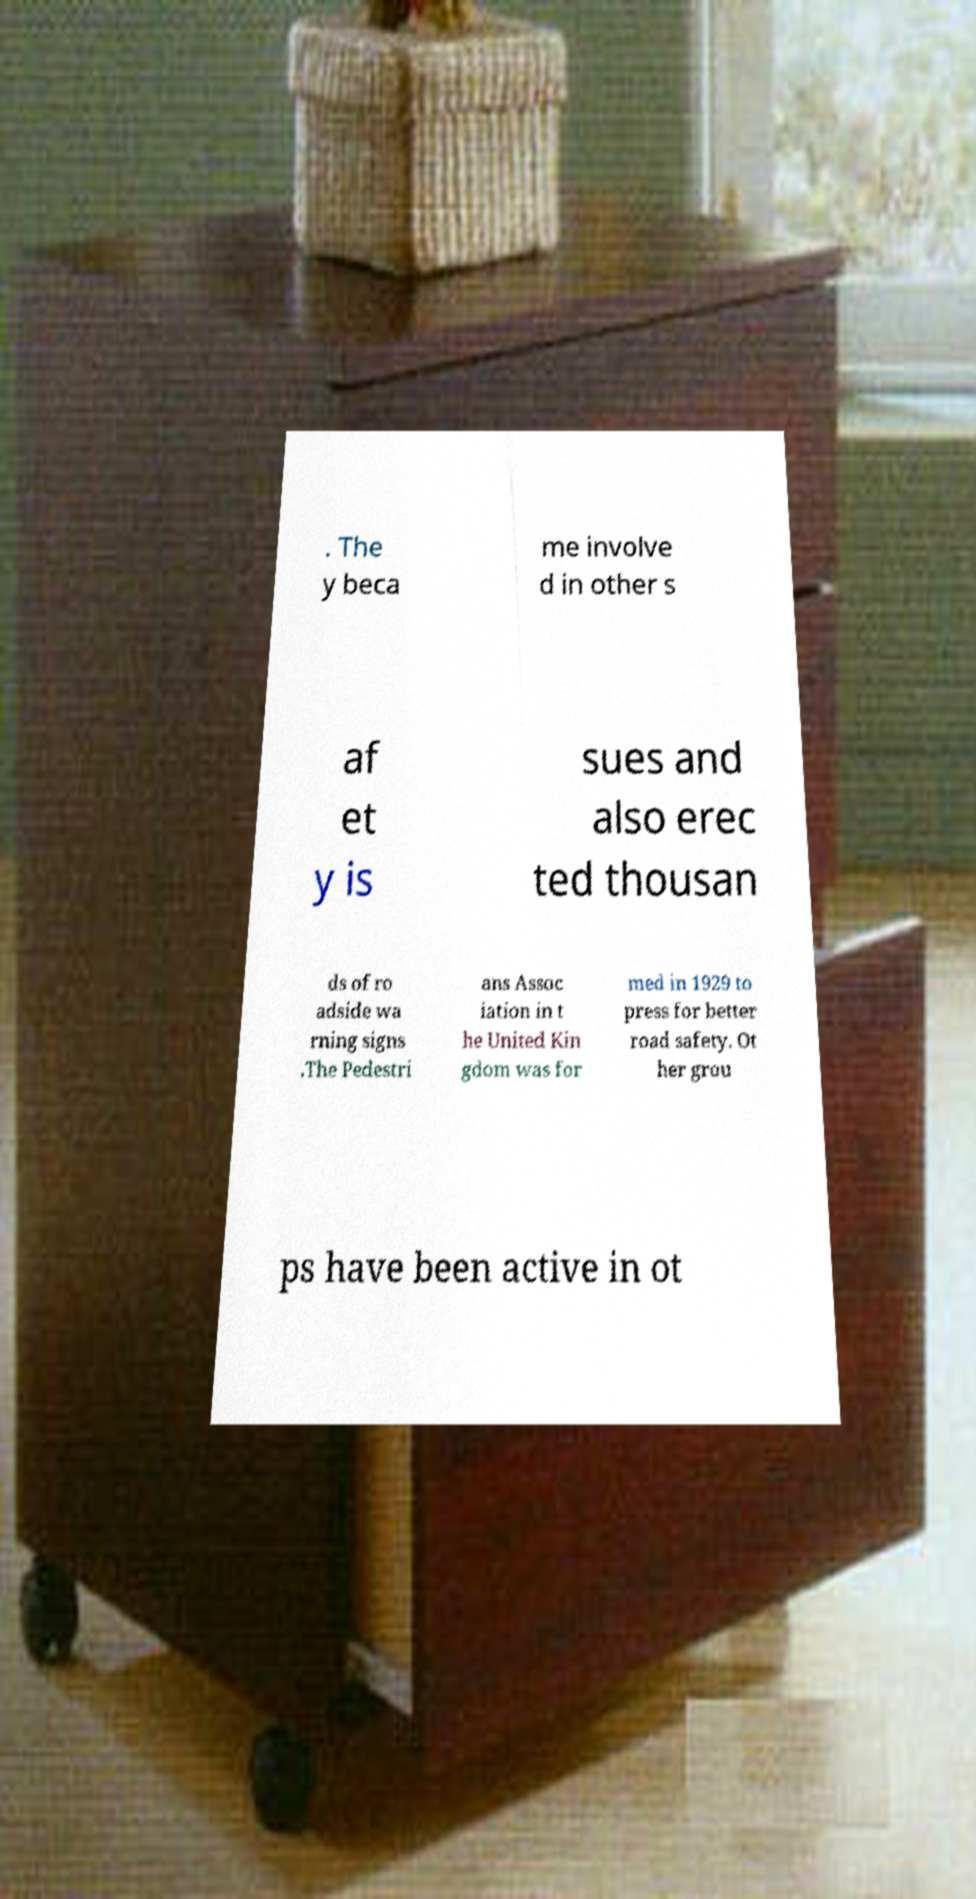For documentation purposes, I need the text within this image transcribed. Could you provide that? . The y beca me involve d in other s af et y is sues and also erec ted thousan ds of ro adside wa rning signs .The Pedestri ans Assoc iation in t he United Kin gdom was for med in 1929 to press for better road safety. Ot her grou ps have been active in ot 